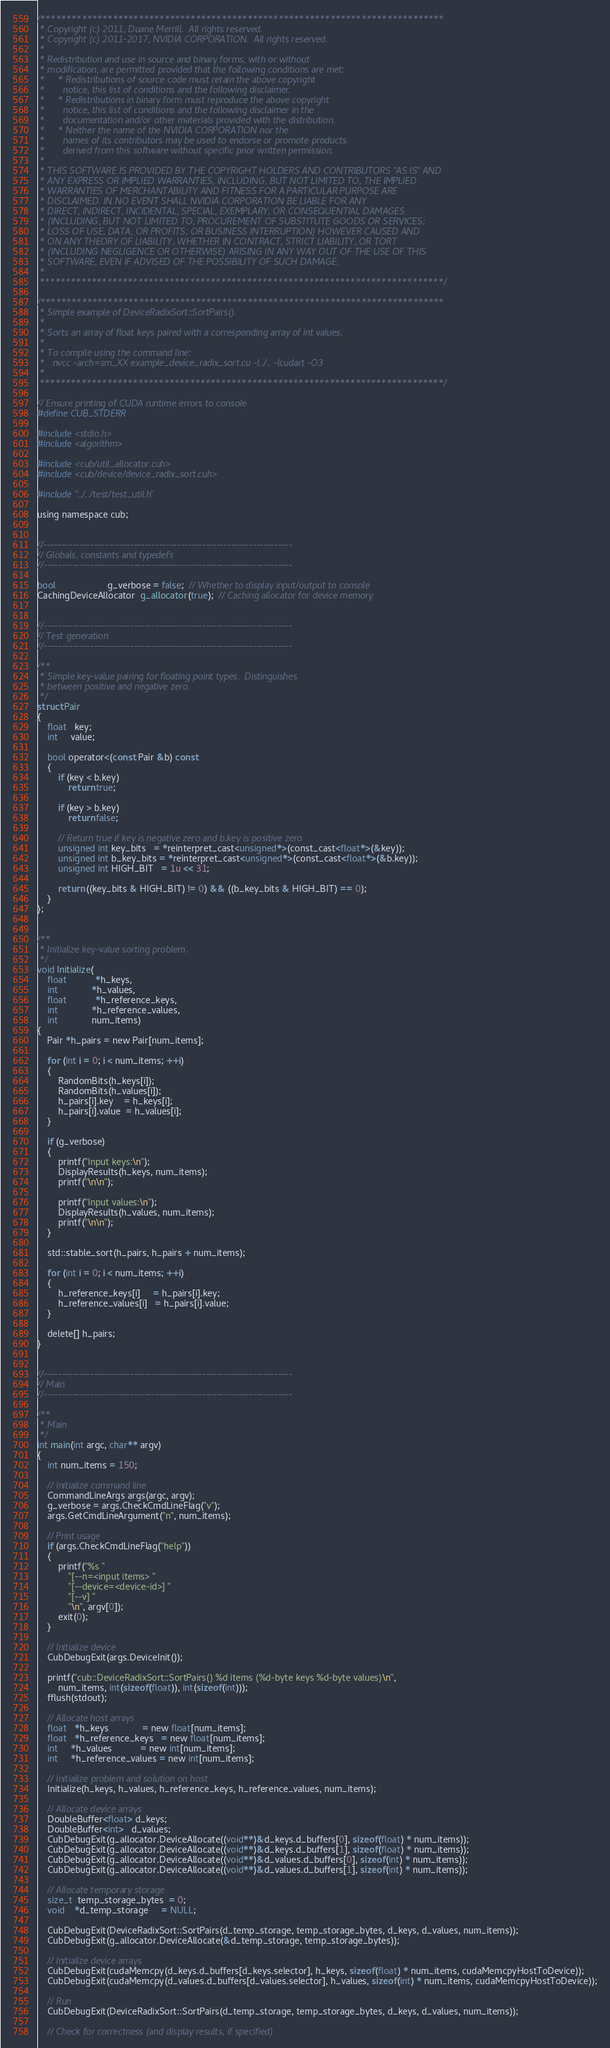Convert code to text. <code><loc_0><loc_0><loc_500><loc_500><_Cuda_>/******************************************************************************
 * Copyright (c) 2011, Duane Merrill.  All rights reserved.
 * Copyright (c) 2011-2017, NVIDIA CORPORATION.  All rights reserved.
 *
 * Redistribution and use in source and binary forms, with or without
 * modification, are permitted provided that the following conditions are met:
 *     * Redistributions of source code must retain the above copyright
 *       notice, this list of conditions and the following disclaimer.
 *     * Redistributions in binary form must reproduce the above copyright
 *       notice, this list of conditions and the following disclaimer in the
 *       documentation and/or other materials provided with the distribution.
 *     * Neither the name of the NVIDIA CORPORATION nor the
 *       names of its contributors may be used to endorse or promote products
 *       derived from this software without specific prior written permission.
 *
 * THIS SOFTWARE IS PROVIDED BY THE COPYRIGHT HOLDERS AND CONTRIBUTORS "AS IS" AND
 * ANY EXPRESS OR IMPLIED WARRANTIES, INCLUDING, BUT NOT LIMITED TO, THE IMPLIED
 * WARRANTIES OF MERCHANTABILITY AND FITNESS FOR A PARTICULAR PURPOSE ARE
 * DISCLAIMED. IN NO EVENT SHALL NVIDIA CORPORATION BE LIABLE FOR ANY
 * DIRECT, INDIRECT, INCIDENTAL, SPECIAL, EXEMPLARY, OR CONSEQUENTIAL DAMAGES
 * (INCLUDING, BUT NOT LIMITED TO, PROCUREMENT OF SUBSTITUTE GOODS OR SERVICES;
 * LOSS OF USE, DATA, OR PROFITS; OR BUSINESS INTERRUPTION) HOWEVER CAUSED AND
 * ON ANY THEORY OF LIABILITY, WHETHER IN CONTRACT, STRICT LIABILITY, OR TORT
 * (INCLUDING NEGLIGENCE OR OTHERWISE) ARISING IN ANY WAY OUT OF THE USE OF THIS
 * SOFTWARE, EVEN IF ADVISED OF THE POSSIBILITY OF SUCH DAMAGE.
 *
 ******************************************************************************/

/******************************************************************************
 * Simple example of DeviceRadixSort::SortPairs().
 *
 * Sorts an array of float keys paired with a corresponding array of int values.
 *
 * To compile using the command line:
 *   nvcc -arch=sm_XX example_device_radix_sort.cu -I../.. -lcudart -O3
 *
 ******************************************************************************/

// Ensure printing of CUDA runtime errors to console
#define CUB_STDERR

#include <stdio.h>
#include <algorithm>

#include <cub/util_allocator.cuh>
#include <cub/device/device_radix_sort.cuh>

#include "../../test/test_util.h"

using namespace cub;


//---------------------------------------------------------------------
// Globals, constants and typedefs
//---------------------------------------------------------------------

bool                    g_verbose = false;  // Whether to display input/output to console
CachingDeviceAllocator  g_allocator(true);  // Caching allocator for device memory


//---------------------------------------------------------------------
// Test generation
//---------------------------------------------------------------------

/**
 * Simple key-value pairing for floating point types.  Distinguishes
 * between positive and negative zero.
 */
struct Pair
{
    float   key;
    int     value;

    bool operator<(const Pair &b) const
    {
        if (key < b.key)
            return true;

        if (key > b.key)
            return false;

        // Return true if key is negative zero and b.key is positive zero
        unsigned int key_bits   = *reinterpret_cast<unsigned*>(const_cast<float*>(&key));
        unsigned int b_key_bits = *reinterpret_cast<unsigned*>(const_cast<float*>(&b.key));
        unsigned int HIGH_BIT   = 1u << 31;

        return ((key_bits & HIGH_BIT) != 0) && ((b_key_bits & HIGH_BIT) == 0);
    }
};


/**
 * Initialize key-value sorting problem.
 */
void Initialize(
    float           *h_keys,
    int             *h_values,
    float           *h_reference_keys,
    int             *h_reference_values,
    int             num_items)
{
    Pair *h_pairs = new Pair[num_items];

    for (int i = 0; i < num_items; ++i)
    {
        RandomBits(h_keys[i]);
        RandomBits(h_values[i]);
        h_pairs[i].key    = h_keys[i];
        h_pairs[i].value  = h_values[i];
    }

    if (g_verbose)
    {
        printf("Input keys:\n");
        DisplayResults(h_keys, num_items);
        printf("\n\n");

        printf("Input values:\n");
        DisplayResults(h_values, num_items);
        printf("\n\n");
    }

    std::stable_sort(h_pairs, h_pairs + num_items);

    for (int i = 0; i < num_items; ++i)
    {
        h_reference_keys[i]     = h_pairs[i].key;
        h_reference_values[i]   = h_pairs[i].value;
    }

    delete[] h_pairs;
}


//---------------------------------------------------------------------
// Main
//---------------------------------------------------------------------

/**
 * Main
 */
int main(int argc, char** argv)
{
    int num_items = 150;

    // Initialize command line
    CommandLineArgs args(argc, argv);
    g_verbose = args.CheckCmdLineFlag("v");
    args.GetCmdLineArgument("n", num_items);

    // Print usage
    if (args.CheckCmdLineFlag("help"))
    {
        printf("%s "
            "[--n=<input items> "
            "[--device=<device-id>] "
            "[--v] "
            "\n", argv[0]);
        exit(0);
    }

    // Initialize device
    CubDebugExit(args.DeviceInit());

    printf("cub::DeviceRadixSort::SortPairs() %d items (%d-byte keys %d-byte values)\n",
        num_items, int(sizeof(float)), int(sizeof(int)));
    fflush(stdout);

    // Allocate host arrays
    float   *h_keys             = new float[num_items];
    float   *h_reference_keys   = new float[num_items];
    int     *h_values           = new int[num_items];
    int     *h_reference_values = new int[num_items];

    // Initialize problem and solution on host
    Initialize(h_keys, h_values, h_reference_keys, h_reference_values, num_items);

    // Allocate device arrays
    DoubleBuffer<float> d_keys;
    DoubleBuffer<int>   d_values;
    CubDebugExit(g_allocator.DeviceAllocate((void**)&d_keys.d_buffers[0], sizeof(float) * num_items));
    CubDebugExit(g_allocator.DeviceAllocate((void**)&d_keys.d_buffers[1], sizeof(float) * num_items));
    CubDebugExit(g_allocator.DeviceAllocate((void**)&d_values.d_buffers[0], sizeof(int) * num_items));
    CubDebugExit(g_allocator.DeviceAllocate((void**)&d_values.d_buffers[1], sizeof(int) * num_items));

    // Allocate temporary storage
    size_t  temp_storage_bytes  = 0;
    void    *d_temp_storage     = NULL;

    CubDebugExit(DeviceRadixSort::SortPairs(d_temp_storage, temp_storage_bytes, d_keys, d_values, num_items));
    CubDebugExit(g_allocator.DeviceAllocate(&d_temp_storage, temp_storage_bytes));

    // Initialize device arrays
    CubDebugExit(cudaMemcpy(d_keys.d_buffers[d_keys.selector], h_keys, sizeof(float) * num_items, cudaMemcpyHostToDevice));
    CubDebugExit(cudaMemcpy(d_values.d_buffers[d_values.selector], h_values, sizeof(int) * num_items, cudaMemcpyHostToDevice));

    // Run
    CubDebugExit(DeviceRadixSort::SortPairs(d_temp_storage, temp_storage_bytes, d_keys, d_values, num_items));

    // Check for correctness (and display results, if specified)</code> 